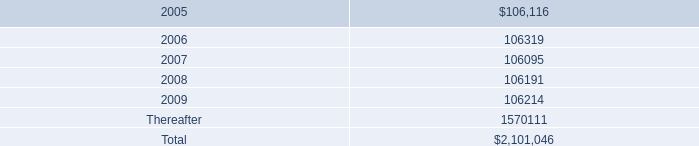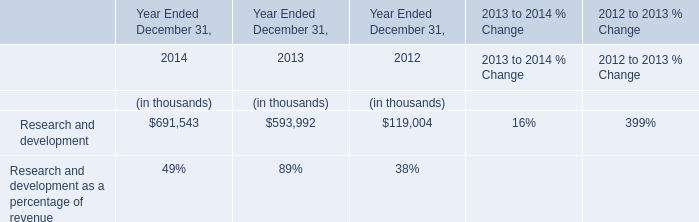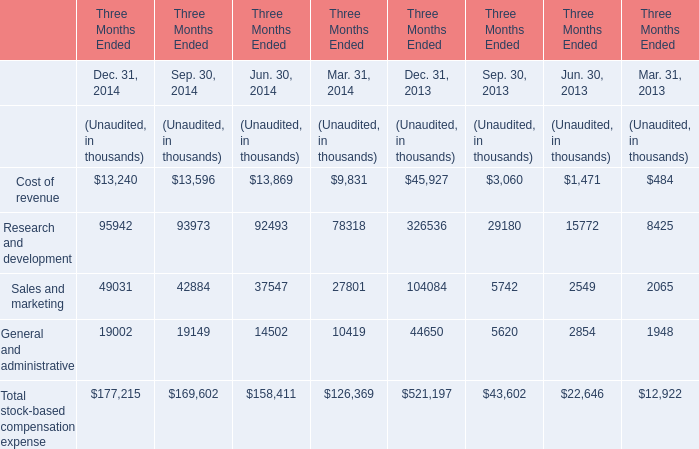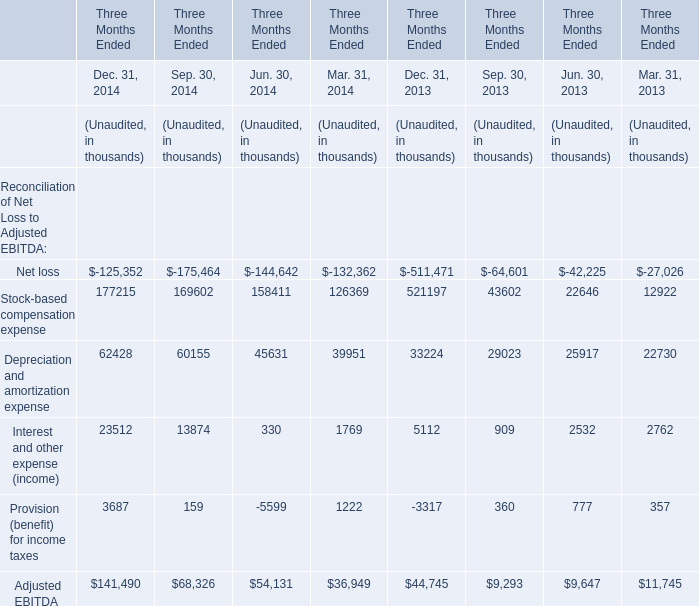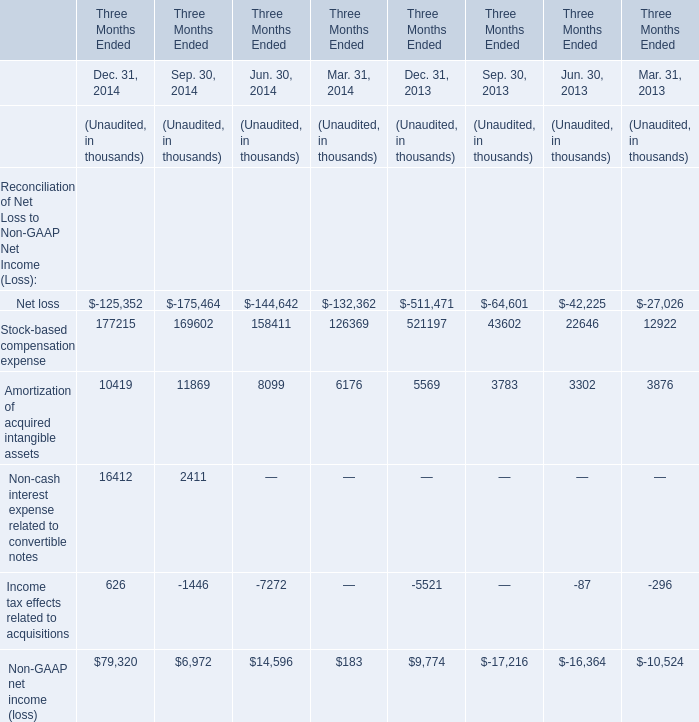What will Amortization of acquired intangible assets be like in 2015 if it develops with the same increasing rate as current? (in thousand) 
Computations: ((((10419 - 5569) / 5569) + 1) * 10419)
Answer: 19492.82834. 